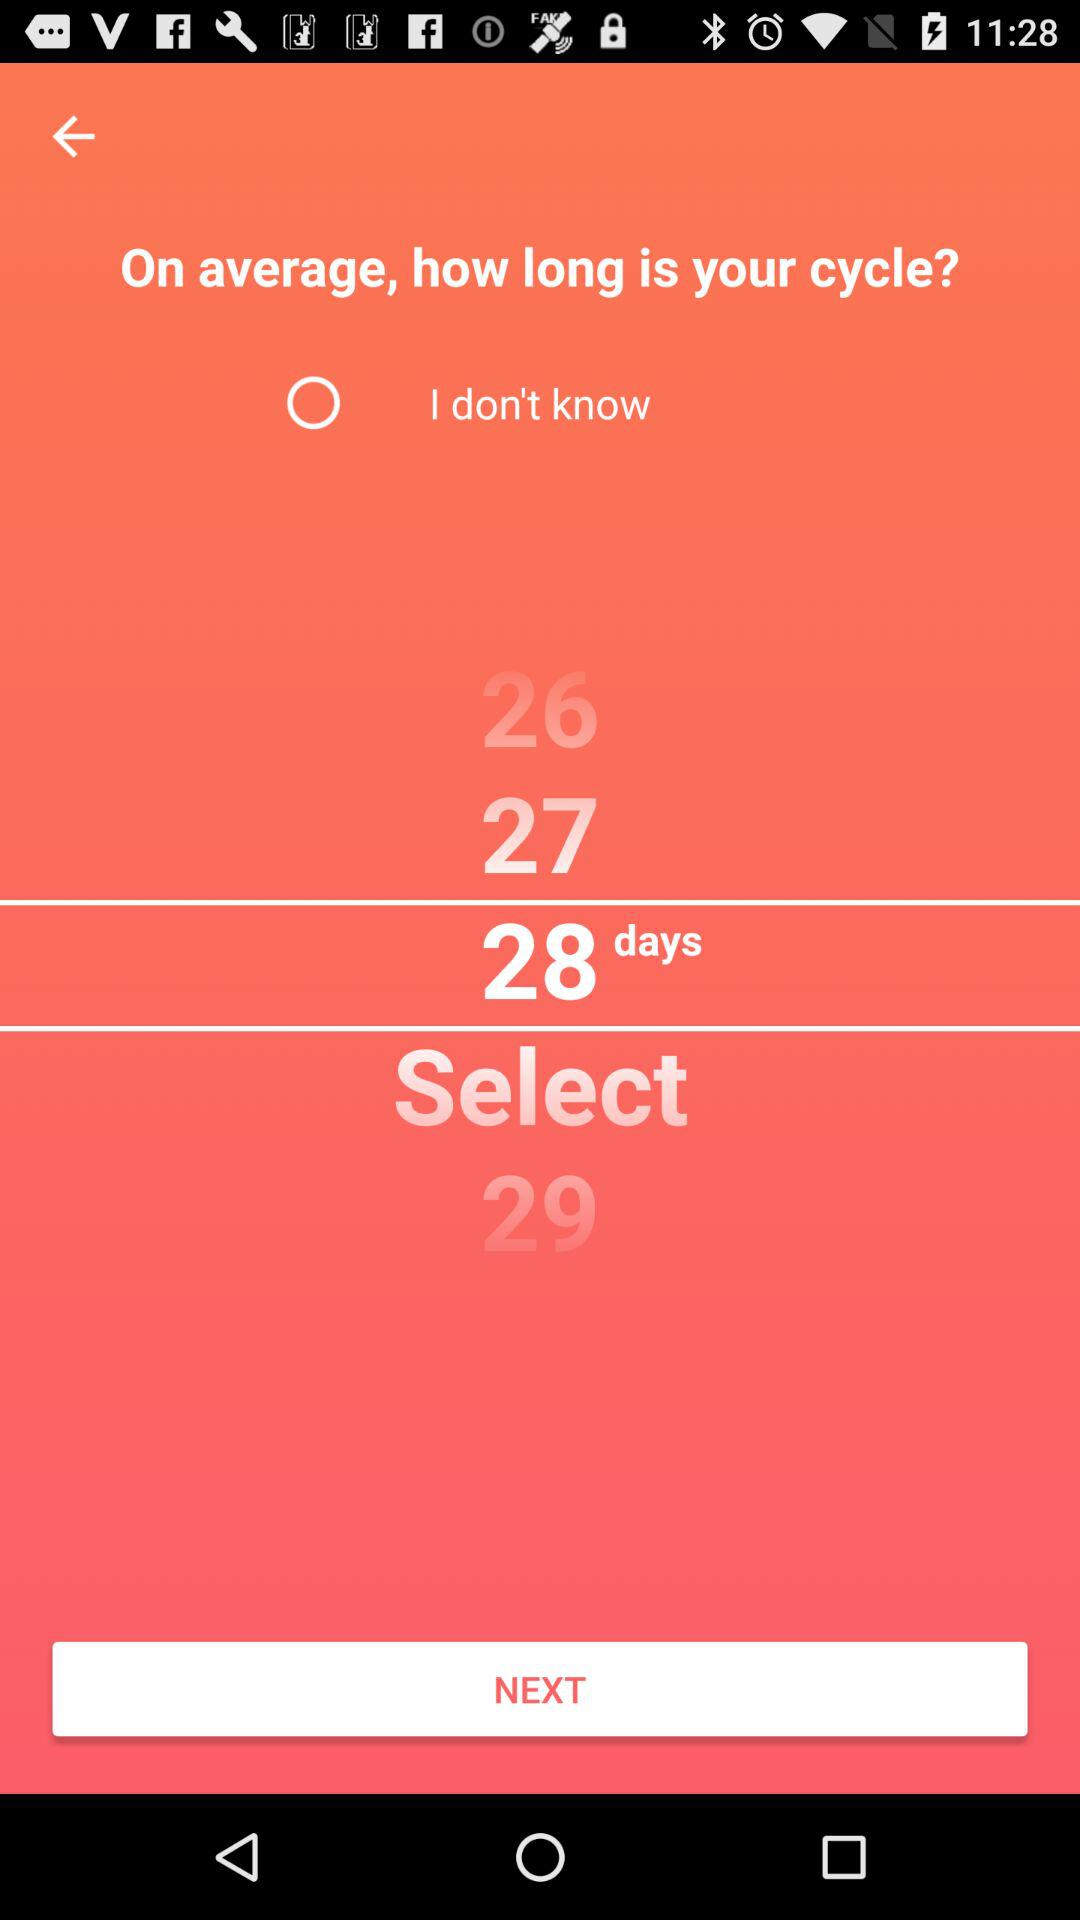Is "I don't know" selected or not? "I don't know" is not selected. 